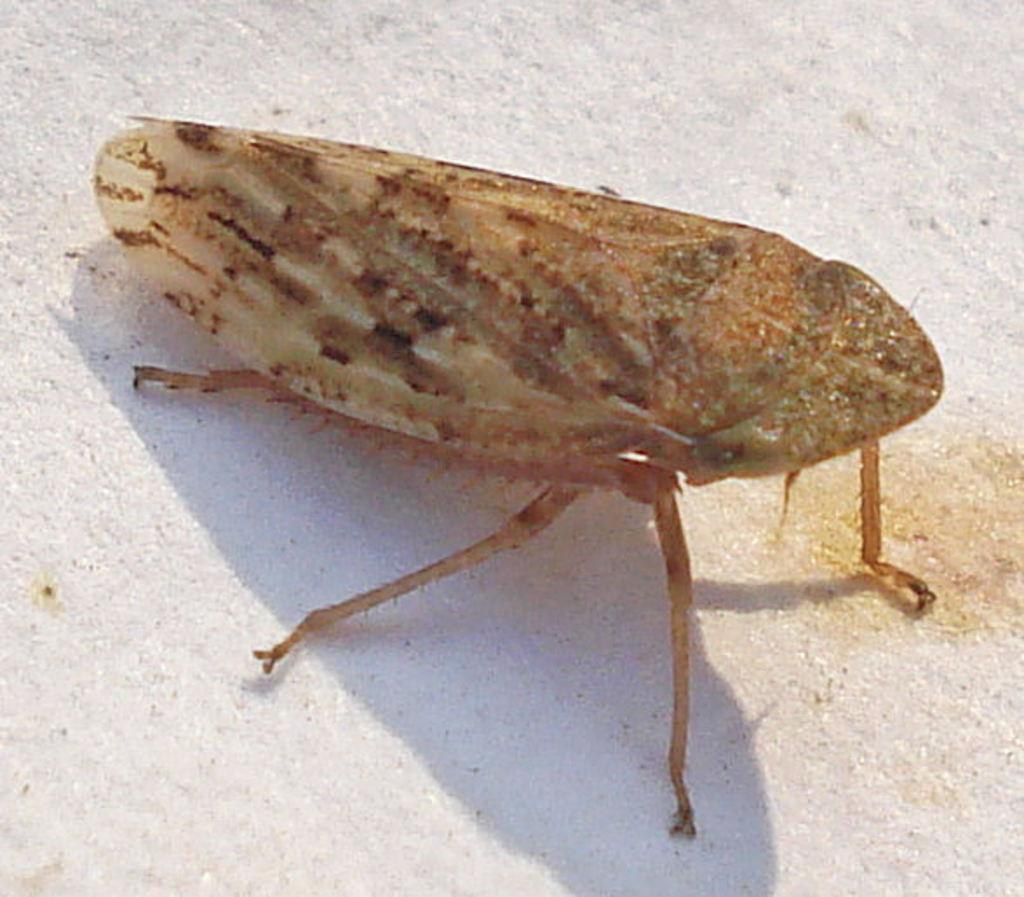Describe this image in one or two sentences. In this image we can see an insect on the surface. 